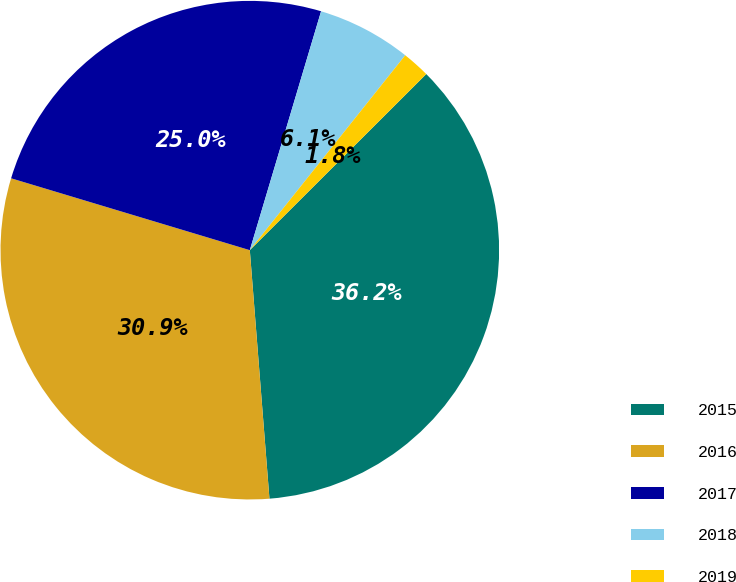<chart> <loc_0><loc_0><loc_500><loc_500><pie_chart><fcel>2015<fcel>2016<fcel>2017<fcel>2018<fcel>2019<nl><fcel>36.23%<fcel>30.91%<fcel>24.96%<fcel>6.1%<fcel>1.8%<nl></chart> 